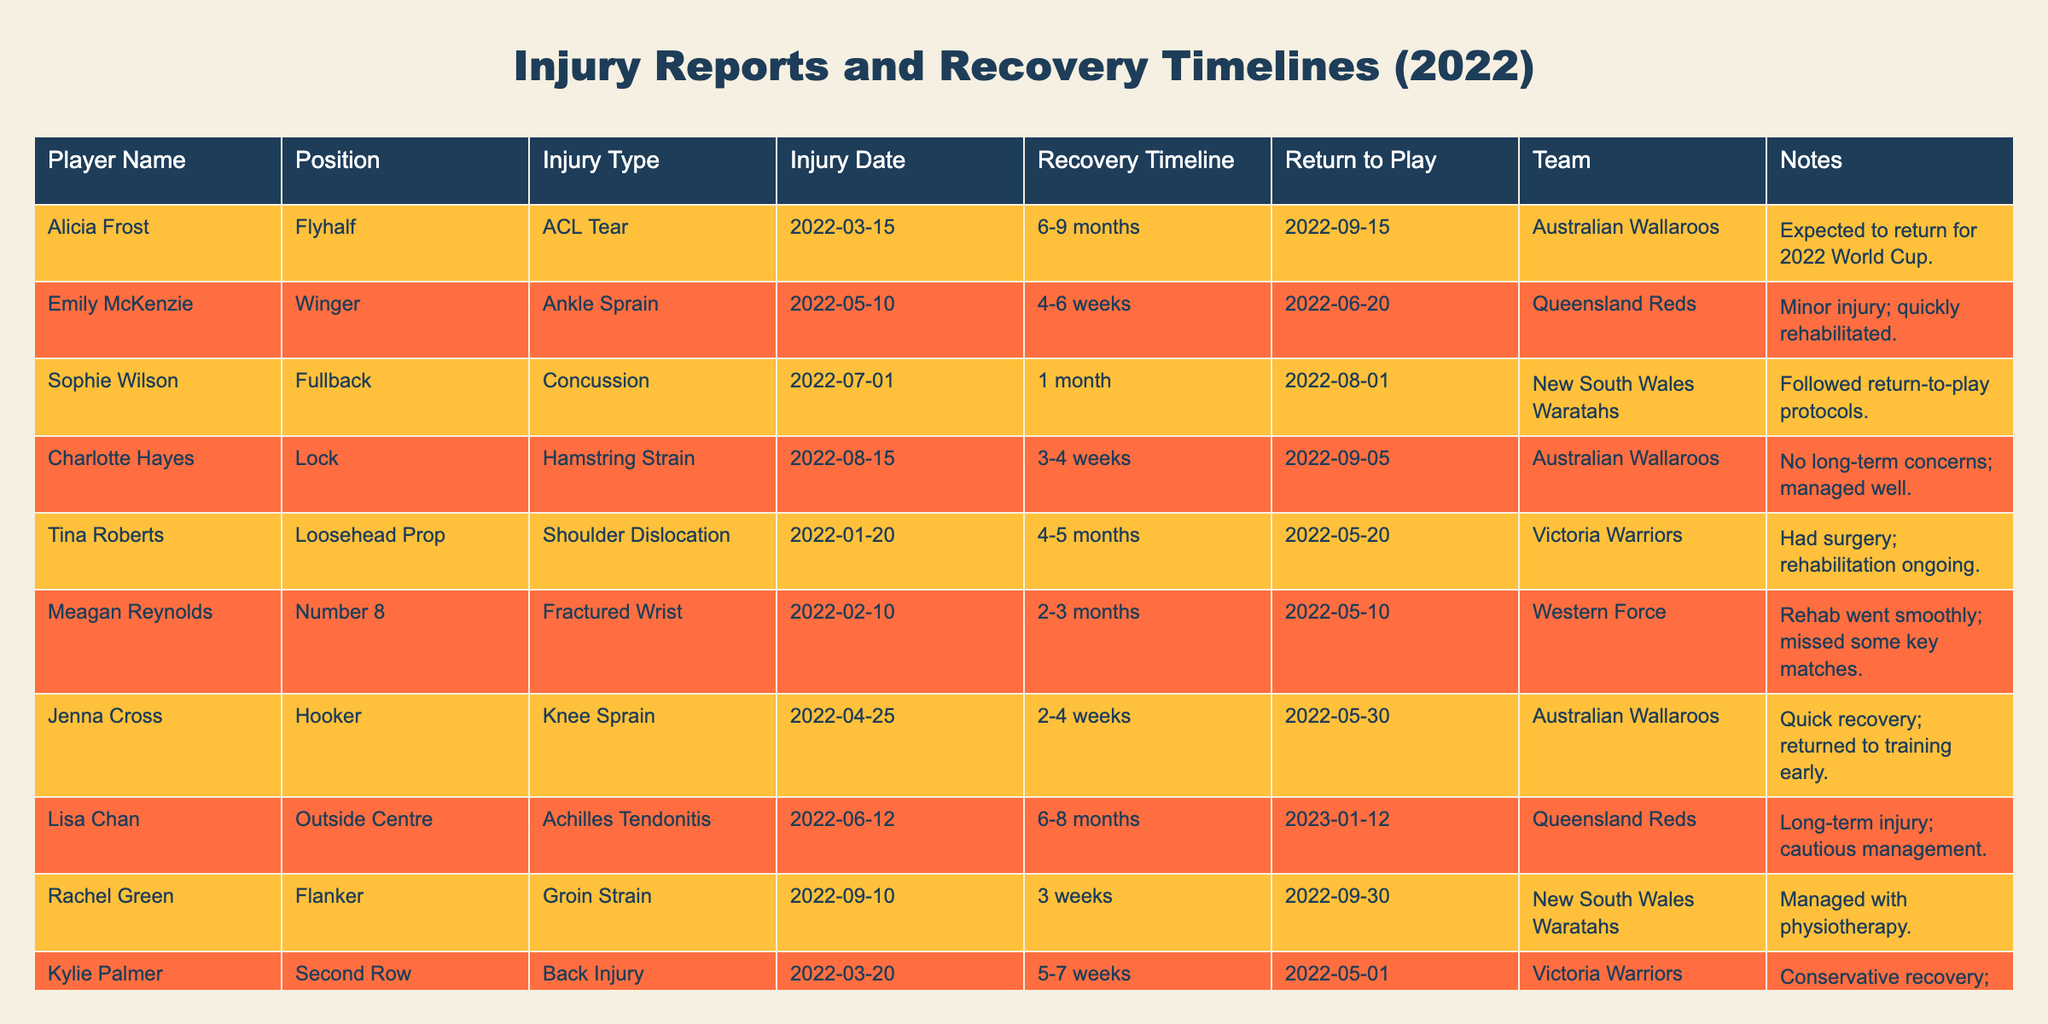What injury did Alicia Frost sustain? The injury type for Alicia Frost listed in the table is an ACL Tear.
Answer: ACL Tear When is Lisa Chan expected to return to play? According to the table, Lisa Chan's return to play is expected on 2023-01-12 as she has a recovery timeline of 6-8 months from the injury date of 2022-06-12.
Answer: 2023-01-12 How many players had injuries that required more than 3 months of recovery? Reviewing the injury timelines, Alicia Frost, Tina Roberts, and Lisa Chan had injuries categorized with recovery timelines longer than 3 months (6-9 months, 4-5 months, and 6-8 months respectively), totaling three players.
Answer: 3 Did any players return to play sooner than their estimated recovery timelines? Yes, both Emily McKenzie and Jenna Cross returned to play sooner than their estimated recovery timelines, with Emily expected to return in 4-6 weeks but coming back in just over 5 weeks and Jenna who had a timeline of 2-4 weeks recovered in 5 weeks.
Answer: Yes What is the average recovery time for the players listed? The recovery timelines are (6-9, 4-6, 1, 3-4, 4-5, 2-3, 2-4, 6-8, 3, 5-7 weeks). Converted to weeks for calculation: (7.5, 5, 4, 3.5, 4.5, 2.5, 3, 7, 3, 6) weeks sum to 45.5 weeks and there are 10 players, so the average is 45.5 / 10 = 4.55 weeks.
Answer: 4.55 weeks Was there a player who sustained a concussion? Yes, Sophie Wilson is listed as having sustained a concussion.
Answer: Yes Which position had the longest recovery timeline? Alicia Frost at the Flyhalf position had the longest recovery timeline of 6-9 months, which is the highest among the recovery timelines listed.
Answer: Flyhalf For which team did Kylie Palmer play? The table indicates that Kylie Palmer played for the Victoria Warriors.
Answer: Victoria Warriors Which player has the shortest recovery timeline? The shortest recovery timeline is for Sophie Wilson, who sustained a concussion with a return expected in 1 month.
Answer: Sophie Wilson What type of injury did Rachel Green sustain? According to the table, Rachel Green sustained a Groin Strain.
Answer: Groin Strain Is there any player who had surgery for their injury? Yes, Tina Roberts had surgery for her shoulder dislocation as noted in the table.
Answer: Yes 